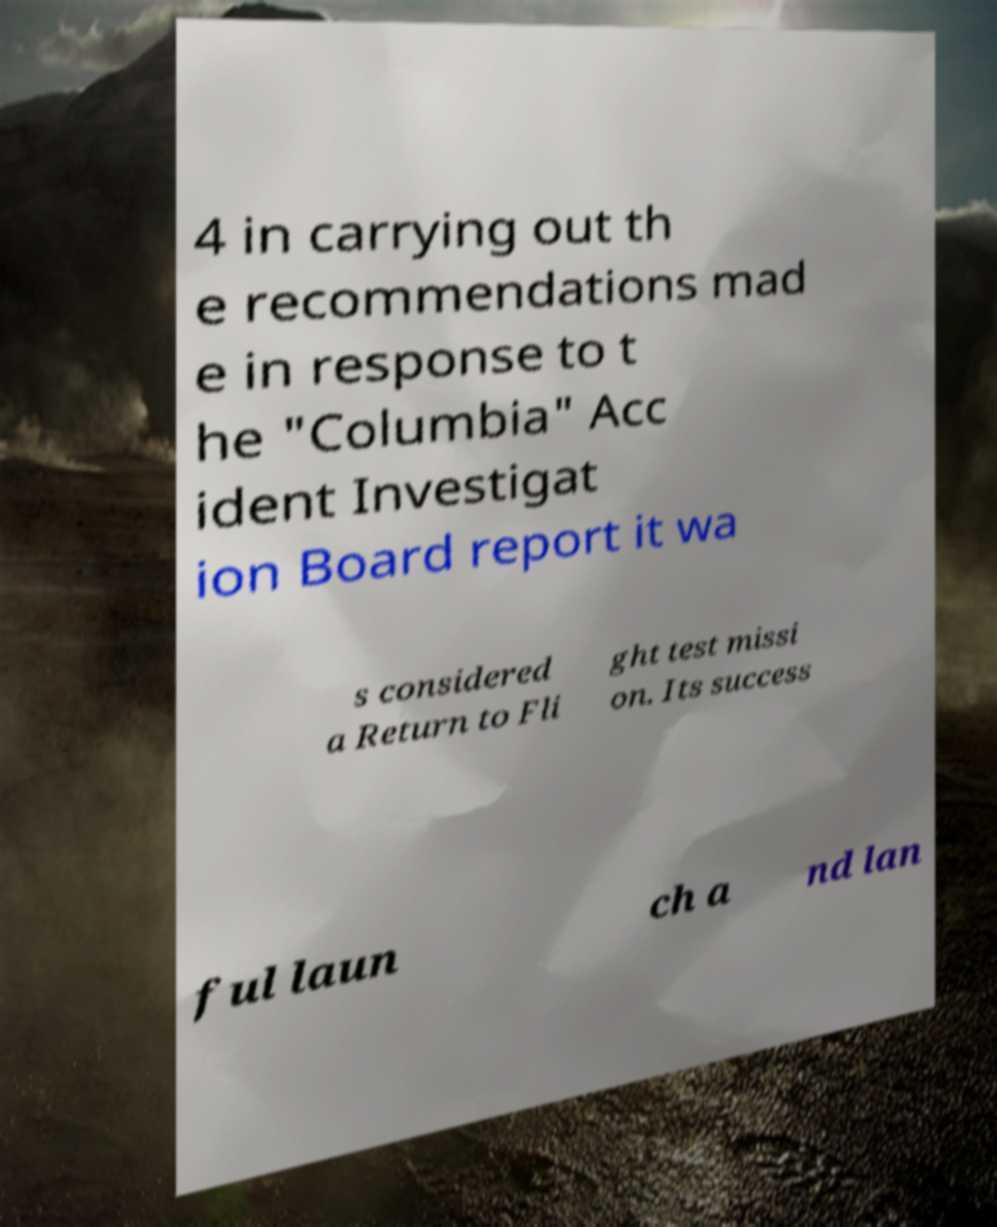Can you accurately transcribe the text from the provided image for me? 4 in carrying out th e recommendations mad e in response to t he "Columbia" Acc ident Investigat ion Board report it wa s considered a Return to Fli ght test missi on. Its success ful laun ch a nd lan 